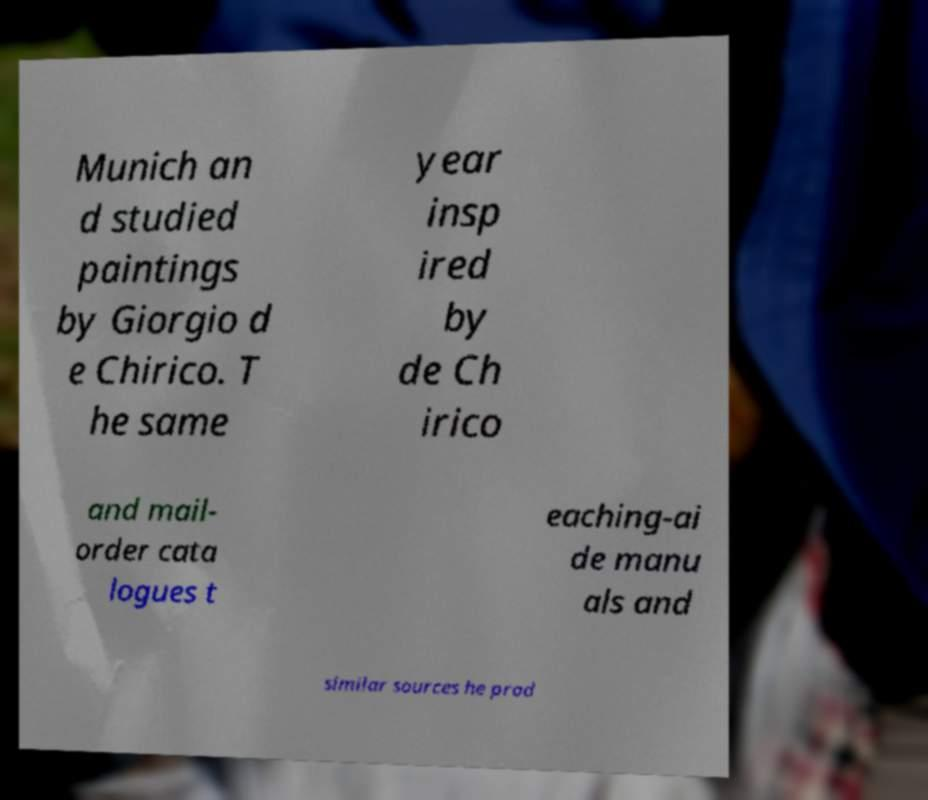Could you assist in decoding the text presented in this image and type it out clearly? Munich an d studied paintings by Giorgio d e Chirico. T he same year insp ired by de Ch irico and mail- order cata logues t eaching-ai de manu als and similar sources he prod 